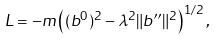<formula> <loc_0><loc_0><loc_500><loc_500>L = - m \left ( ( b ^ { 0 } ) ^ { 2 } - \lambda ^ { 2 } \| b ^ { \prime \prime } \| ^ { 2 } \right ) ^ { 1 / 2 } ,</formula> 